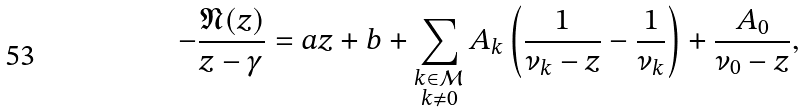<formula> <loc_0><loc_0><loc_500><loc_500>- \frac { \mathfrak { N } ( z ) } { z - \gamma } = a z + b + \sum _ { \substack { k \in \mathcal { M } \\ k \not = 0 } } A _ { k } \left ( \frac { 1 } { \nu _ { k } - z } - \frac { 1 } { \nu _ { k } } \right ) + \frac { A _ { 0 } } { \nu _ { 0 } - z } ,</formula> 